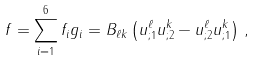Convert formula to latex. <formula><loc_0><loc_0><loc_500><loc_500>f = \sum _ { i = 1 } ^ { 6 } f _ { i } g _ { i } = B _ { \ell k } \left ( u ^ { \ell } _ { ; 1 } u ^ { k } _ { ; 2 } - u ^ { \ell } _ { ; 2 } u ^ { k } _ { ; 1 } \right ) \, ,</formula> 